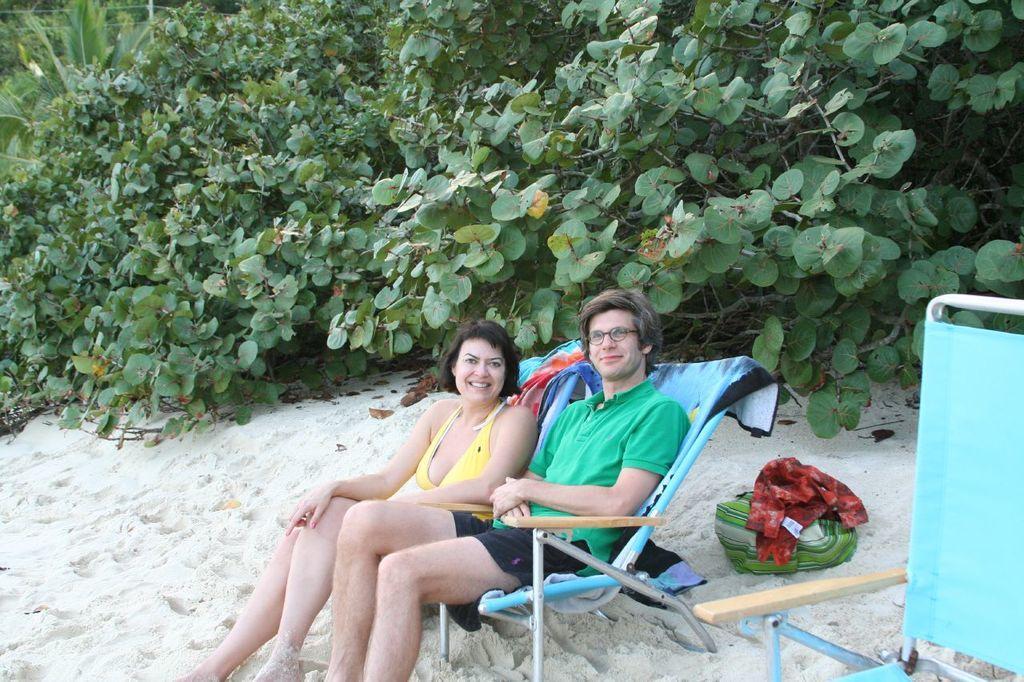Describe this image in one or two sentences. In this image we can see two persons sitting on chairs and posing for a photo and there is a chair on the right side of the image and we can see some objects on the ground. There are some trees in the background. 